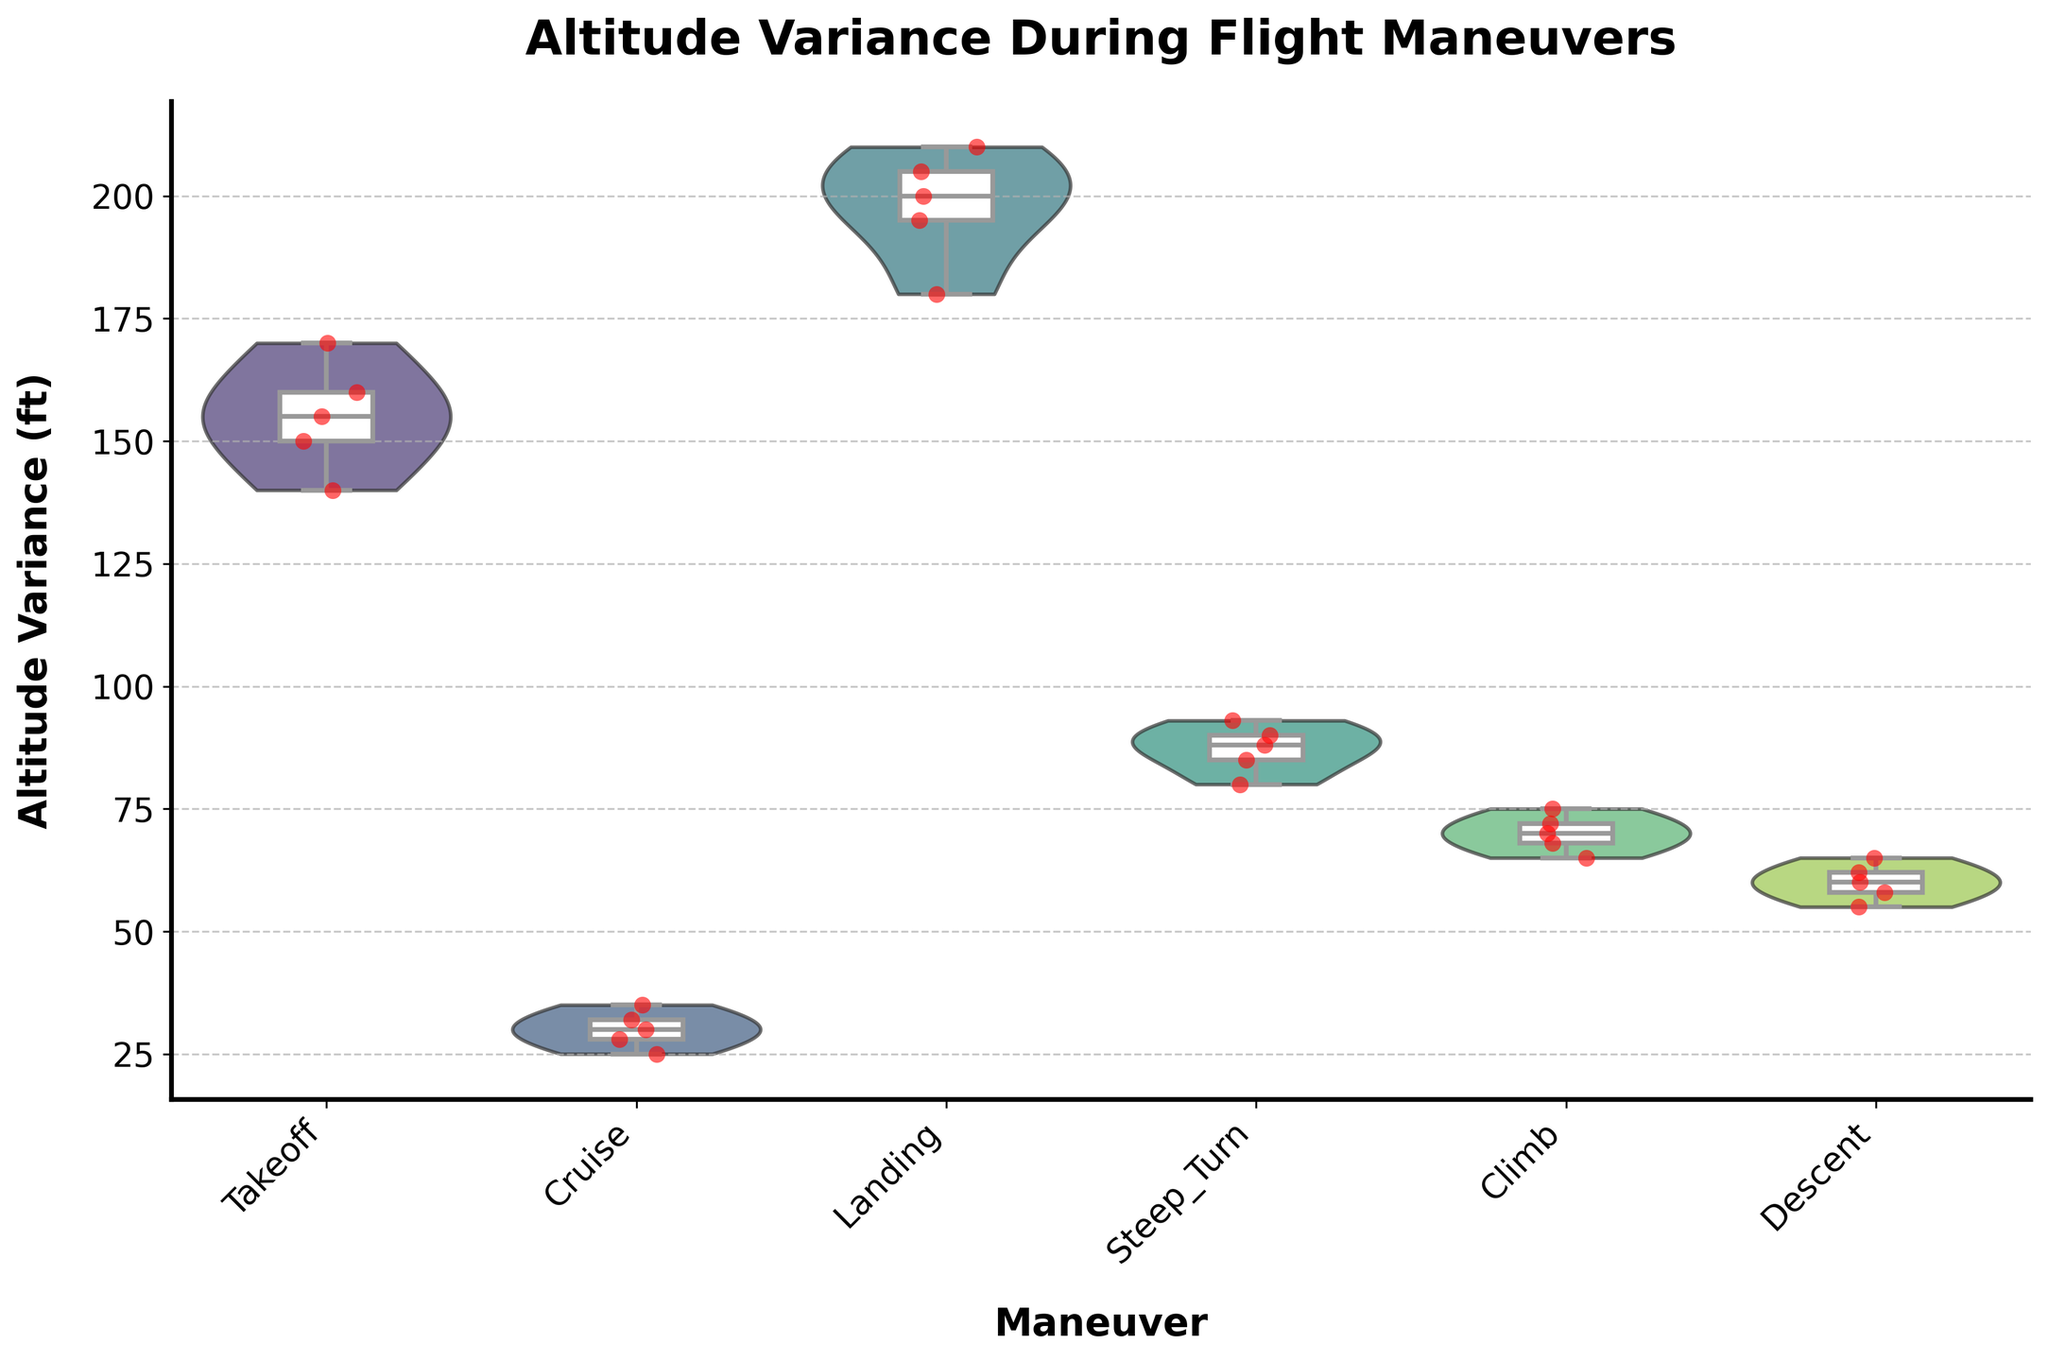What is the title of the chart? The title is typically located at the top of the chart and is designed to give an immediate understanding of what the chart represents.
Answer: Altitude Variance During Flight Maneuvers What is the y-axis label? The y-axis label is displayed on the vertical axis and shows what the y-values represent.
Answer: Altitude Variance (ft) Which maneuver shows the highest median altitude variance? From the box plots overlay, the line in the middle of each box represents the median. By comparing these, we can determine the highest median value.
Answer: Landing How many different maneuvers are displayed on the x-axis? To find out the number of unique maneuvers, count the different category labels on the x-axis.
Answer: Six Which maneuver has the smallest interquartile range (IQR) in altitude variance? The IQR is the range between the first quartile (25th percentile) and the third quartile (75th percentile) in the box plot. By comparing the width of each box, we can determine the smallest IQR.
Answer: Cruise What is the range of altitude variance for the Takeoff maneuver? The range is the difference between the maximum and minimum values. For Takeoff, observe the ends of the violin plot or the whiskers of the box plot.
Answer: 140 to 170 ft Between Climb and Descent, which has a higher mean altitude variance? The mean can be estimated by looking at the density distribution of the violin plot; the peak position indicates the mean. Comparing these peaks will show which has a higher mean.
Answer: Climb Which maneuver has the most dispersed altitude variance data? The most dispersed data can be identified by the width and length of the violin plot. The fatter and longer the plot, the more dispersed the data.
Answer: Landing Is there any maneuver where altitude variance data points are tightly clustered around a single value? Tightly clustered data points will have a narrower violin and closely spaced strip points.
Answer: Yes, Cruise How does the variability in altitude during Steep Turn compare to that during Takeoff? This can be observed by comparing the width and overall spread of the violin plots and the length of whiskers in the box plots.
Answer: Less variable 